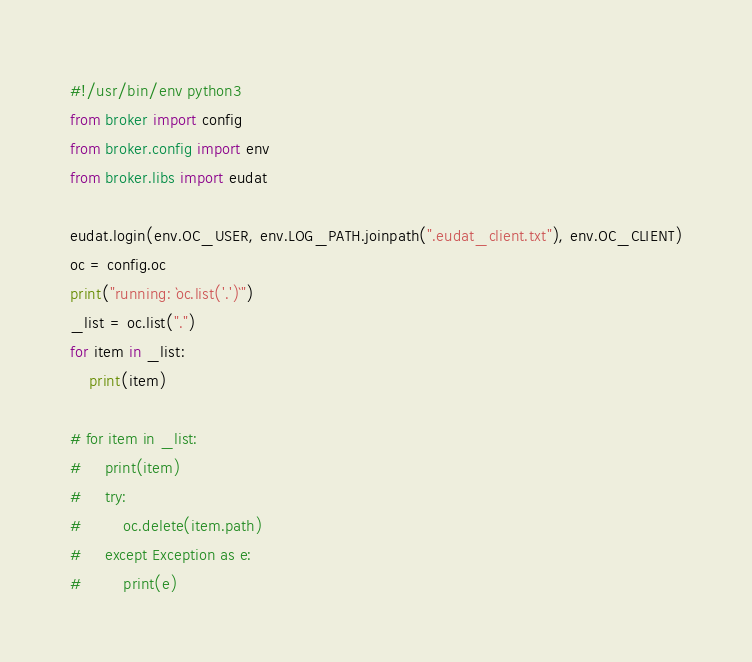<code> <loc_0><loc_0><loc_500><loc_500><_Python_>#!/usr/bin/env python3
from broker import config
from broker.config import env
from broker.libs import eudat

eudat.login(env.OC_USER, env.LOG_PATH.joinpath(".eudat_client.txt"), env.OC_CLIENT)
oc = config.oc
print("running: `oc.list('.')`")
_list = oc.list(".")
for item in _list:
    print(item)

# for item in _list:
#     print(item)
#     try:
#         oc.delete(item.path)
#     except Exception as e:
#         print(e)
</code> 